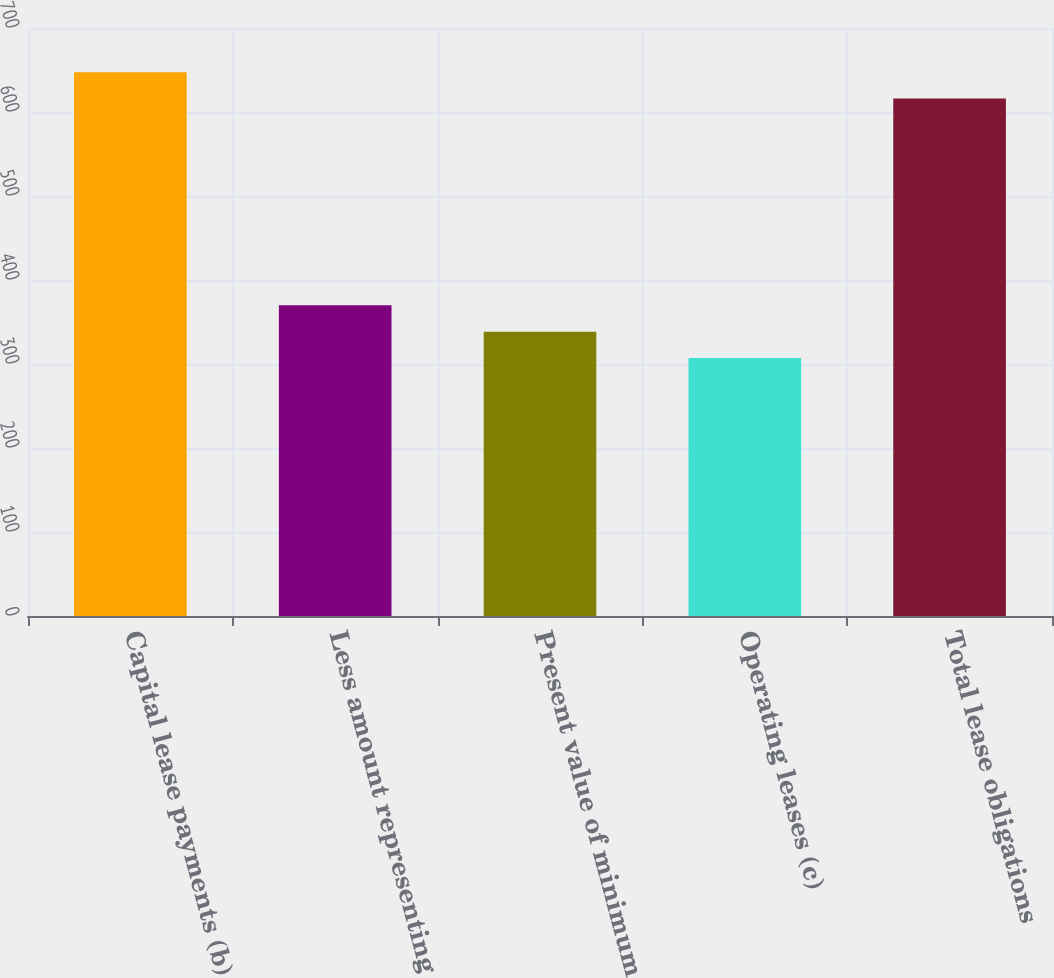Convert chart to OTSL. <chart><loc_0><loc_0><loc_500><loc_500><bar_chart><fcel>Capital lease payments (b)<fcel>Less amount representing<fcel>Present value of minimum<fcel>Operating leases (c)<fcel>Total lease obligations<nl><fcel>647.4<fcel>369.8<fcel>338.4<fcel>307<fcel>616<nl></chart> 